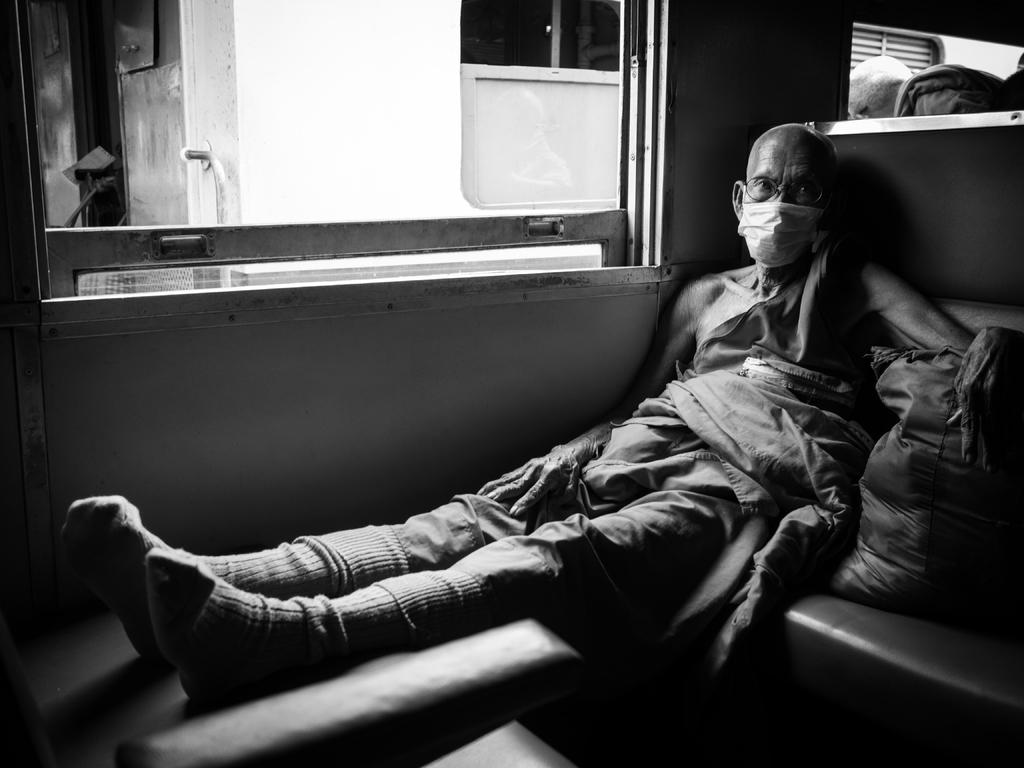What is the person in the image doing? There is a person sitting on a seat in the image. What is the person holding or carrying in the image? There is a bag in the image. What is visible in the background of the image? There is a wall and windows in the image. Can you describe any other objects in the image? There are some objects in the image. What type of dress is the deer wearing in the image? There is no deer or dress present in the image. Can you describe the locket that the person is holding in the image? There is no locket mentioned or visible in the image. 